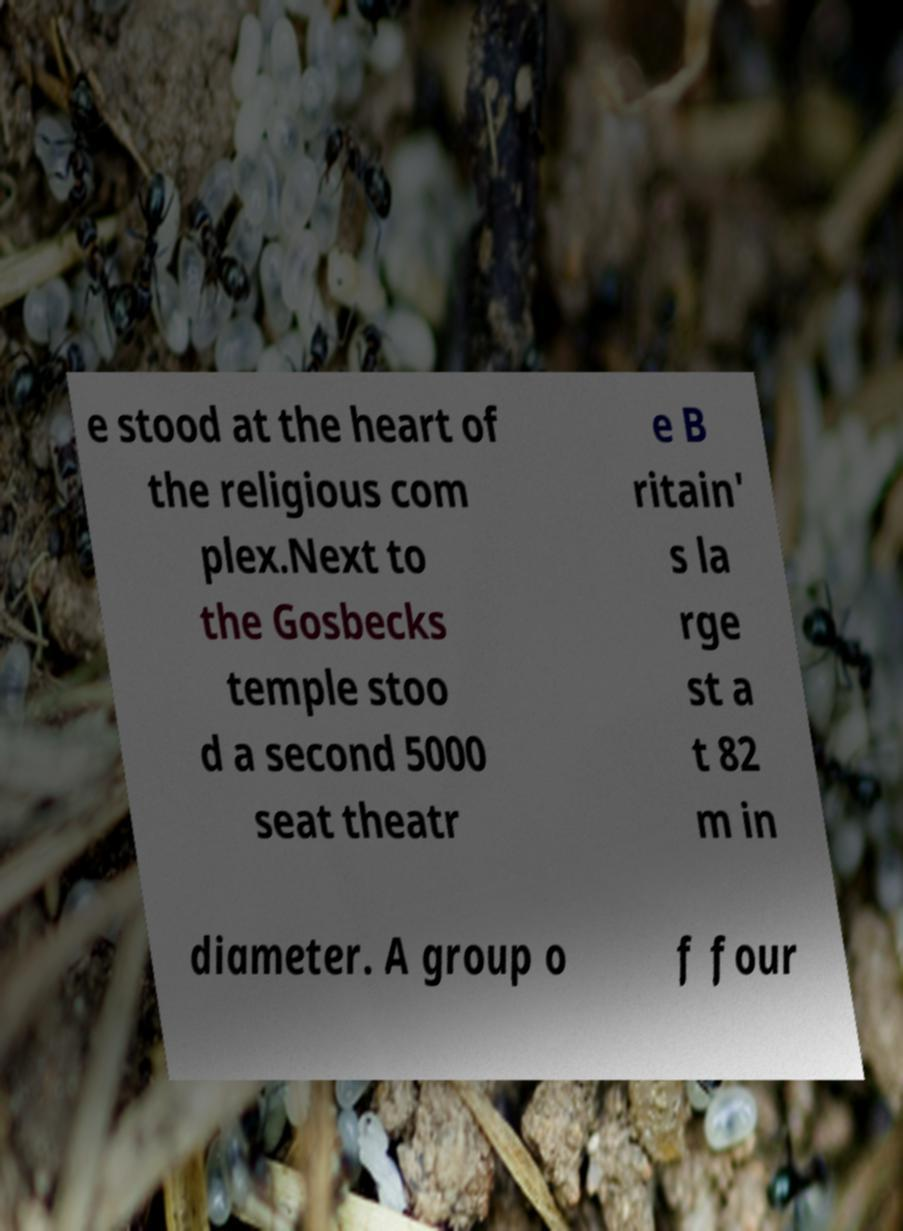Please read and relay the text visible in this image. What does it say? e stood at the heart of the religious com plex.Next to the Gosbecks temple stoo d a second 5000 seat theatr e B ritain' s la rge st a t 82 m in diameter. A group o f four 